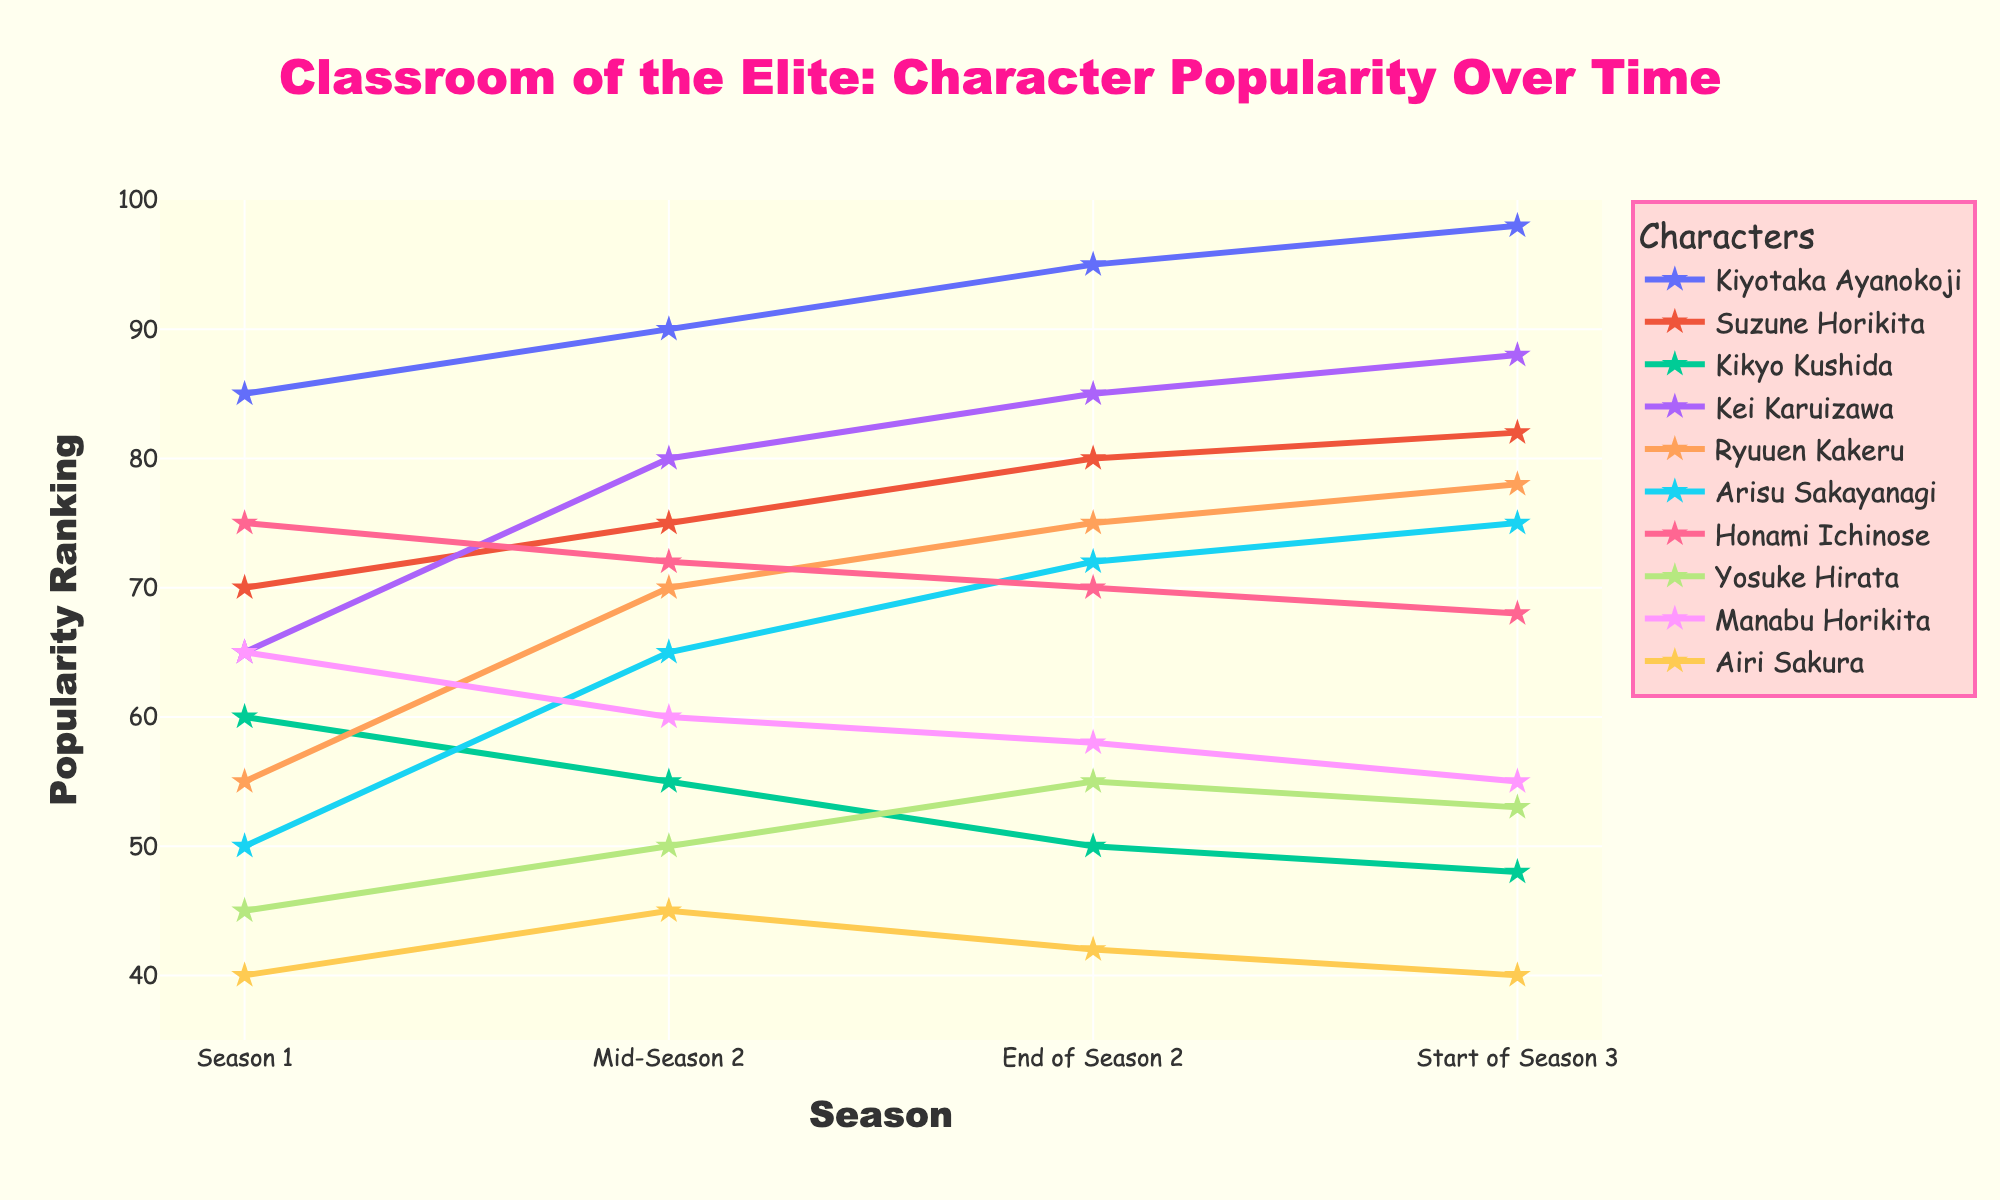What is the popularity ranking of Kiyotaka Ayanokoji at the end of Season 2? Visually locate the line corresponding to Kiyotaka Ayanokoji, then track the point that lines up with 'End of Season 2'. The number next to that point represents the popularity ranking.
Answer: 95 Among Suzune Horikita, Kei Karuizawa, and Ryuuen Kakeru, who has the highest popularity ranking at the start of Season 3? Find the lines for Suzune Horikita, Kei Karuizawa, and Ryuuen Kakeru, then compare their y-values at the 'Start of Season 3'. The highest y-value indicates the highest ranking.
Answer: Kei Karuizawa Who showed the most consistent increase in popularity from Season 1 to the start of Season 3? Identify the character whose line shows a continuous upward trend without any decline from Season 1 to the start of Season 3. Check the character's y-values to ensure they consistently rise.
Answer: Kiyotaka Ayanokoji Calculate the average popularity ranking of Honami Ichinose over the listed periods. Add the popularity rankings of Honami Ichinose for all listed periods: 75 (Season 1), 72 (Mid-Season 2), 70 (End of Season 2), and 68 (Start of Season 3). Then, divide the sum by the number of periods (4).
Answer: 71.25 Is there any character who has a decreasing popularity trend throughout all periods? Look for a character whose line graph shows a consistent downward slope from Season 1 to the start of Season 3. Verify by checking the y-values in each period.
Answer: Kikyo Kushida Which character has the closest popularity ranking to Ryuuen Kakeru at the end of Season 2? Identify the line for Ryuuen Kakeru and note his popularity at 'End of Season 2' (75). Then find the character whose ranking is nearest to this value.
Answer: Kei Karuizawa What is the largest drop in popularity for any character between two consecutive periods? Check the differences in popularity rankings for all characters between each consecutive period and find the maximum drop. For instance, find the difference between Mid-Season 2 and End of Season 2 for each character, and so on.
Answer: Kikyo Kushida (from Season 1 to Mid-Season 2: 60 to 55, drop of 5 points) Compare the popularity ranking change of Airi Sakura and Manabu Horikita from Season 1 to the start of Season 3. Who had the bigger change? Calculate the change for both characters from Season 1 to the start of Season 3. For Airi Sakura: 40 to 40 (0 change). For Manabu Horikita: 65 to 55 (10 change). The change in Manabu Horikita's ranking is larger.
Answer: Manabu Horikita If you average the popularity rankings of Suzune Horikita and Kiyotaka Ayanokoji at the 'Mid-Season 2', what is the result? Add the popularity rankings of Suzune Horikita (75) and Kiyotaka Ayanokoji (90) at 'Mid-Season 2', then divide the sum by 2 to find the average.
Answer: 82.5 Is there any character's popularity that decreased in Mid-Season 2 compared to Season 1 and then increased again by the start of Season 3? Evaluate each character's popularity from Season 1 to Mid-Season 2, and then from Mid-Season 2 to Start of Season 3. Look for a decrease followed by an increase.
Answer: Honami Ichinose 